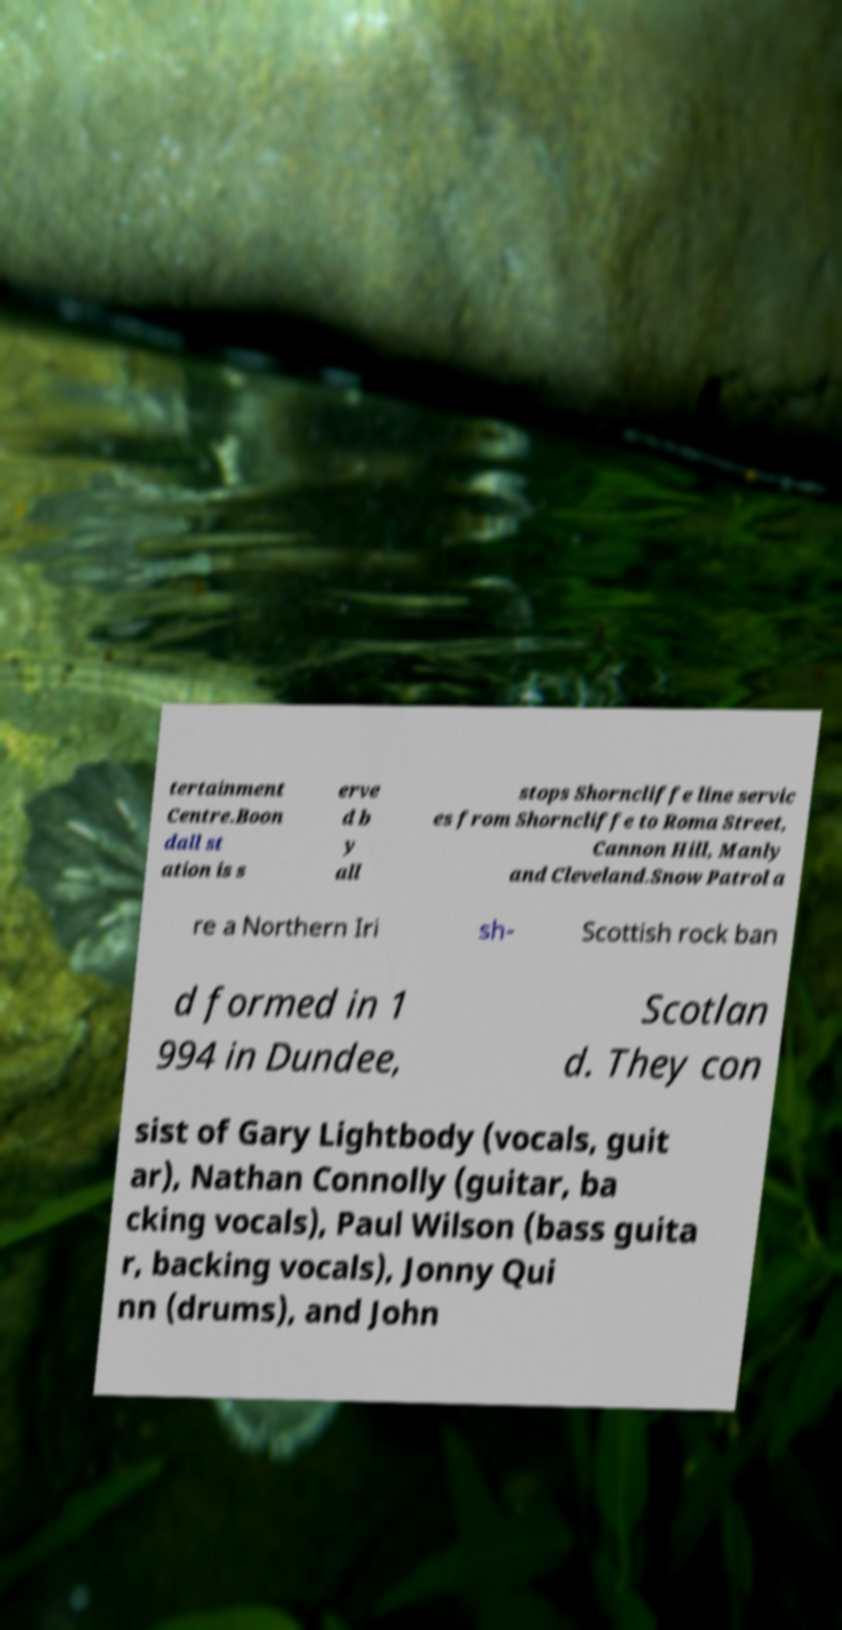There's text embedded in this image that I need extracted. Can you transcribe it verbatim? tertainment Centre.Boon dall st ation is s erve d b y all stops Shorncliffe line servic es from Shorncliffe to Roma Street, Cannon Hill, Manly and Cleveland.Snow Patrol a re a Northern Iri sh- Scottish rock ban d formed in 1 994 in Dundee, Scotlan d. They con sist of Gary Lightbody (vocals, guit ar), Nathan Connolly (guitar, ba cking vocals), Paul Wilson (bass guita r, backing vocals), Jonny Qui nn (drums), and John 